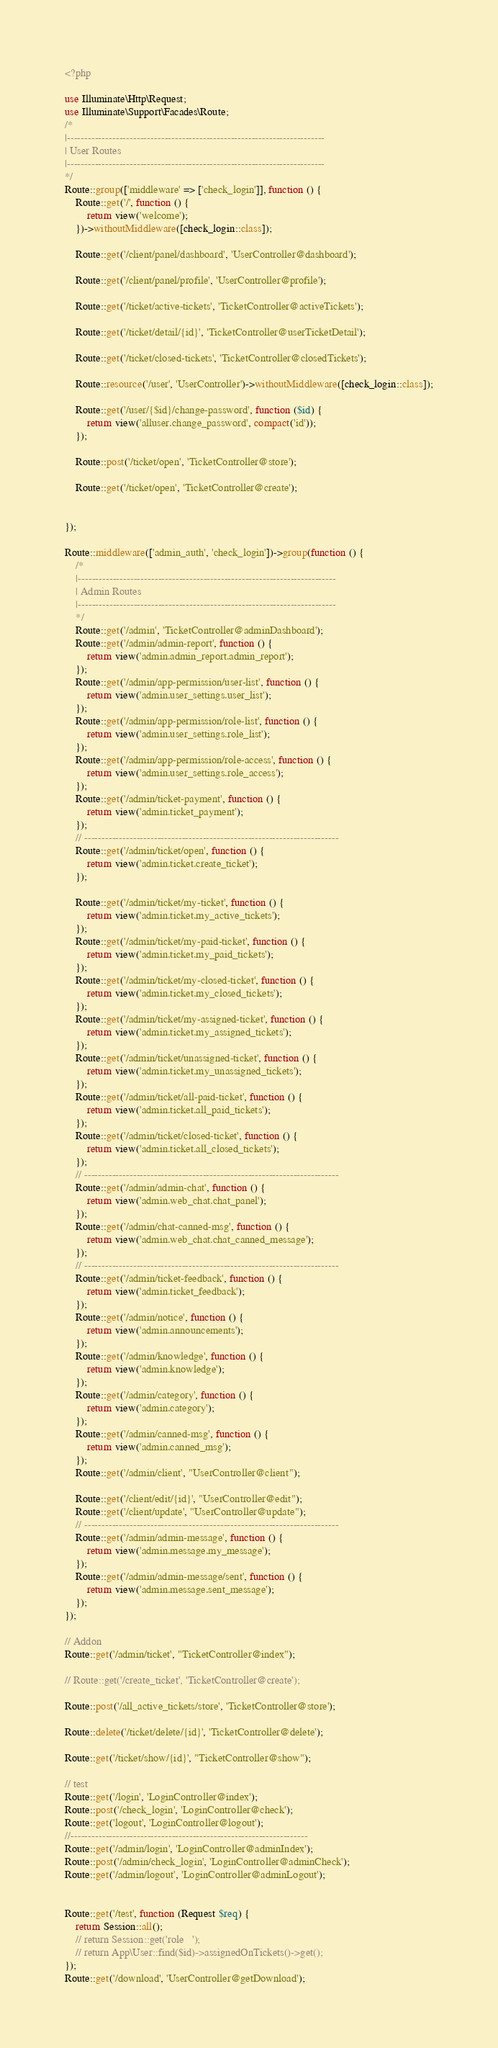Convert code to text. <code><loc_0><loc_0><loc_500><loc_500><_PHP_><?php

use Illuminate\Http\Request;
use Illuminate\Support\Facades\Route;
/*
|--------------------------------------------------------------------------
| User Routes
|--------------------------------------------------------------------------
*/
Route::group(['middleware' => ['check_login']], function () {
    Route::get('/', function () {
        return view('welcome'); 
    })->withoutMiddleware([check_login::class]);

    Route::get('/client/panel/dashboard', 'UserController@dashboard');
    
    Route::get('/client/panel/profile', 'UserController@profile');

    Route::get('/ticket/active-tickets', 'TicketController@activeTickets');

    Route::get('/ticket/detail/{id}', 'TicketController@userTicketDetail');

    Route::get('/ticket/closed-tickets', 'TicketController@closedTickets');

    Route::resource('/user', 'UserController')->withoutMiddleware([check_login::class]);
      
    Route::get('/user/{$id}/change-password', function ($id) {
        return view('alluser.change_password', compact('id'));
    });
    
    Route::post('/ticket/open', 'TicketController@store');

    Route::get('/ticket/open', 'TicketController@create');

    
});

Route::middleware(['admin_auth', 'check_login'])->group(function () {
    /*
    |--------------------------------------------------------------------------
    | Admin Routes
    |--------------------------------------------------------------------------
    */
    Route::get('/admin', 'TicketController@adminDashboard');
    Route::get('/admin/admin-report', function () {
        return view('admin.admin_report.admin_report');
    });
    Route::get('/admin/app-permission/user-list', function () {
        return view('admin.user_settings.user_list');
    });
    Route::get('/admin/app-permission/role-list', function () {
        return view('admin.user_settings.role_list');
    });
    Route::get('/admin/app-permission/role-access', function () {
        return view('admin.user_settings.role_access');
    });
    Route::get('/admin/ticket-payment', function () {
        return view('admin.ticket_payment');
    });
    // -------------------------------------------------------------------------
    Route::get('/admin/ticket/open', function () {
        return view('admin.ticket.create_ticket');
    });

    Route::get('/admin/ticket/my-ticket', function () {
        return view('admin.ticket.my_active_tickets');
    });
    Route::get('/admin/ticket/my-paid-ticket', function () {
        return view('admin.ticket.my_paid_tickets');
    });
    Route::get('/admin/ticket/my-closed-ticket', function () {
        return view('admin.ticket.my_closed_tickets');
    });
    Route::get('/admin/ticket/my-assigned-ticket', function () {
        return view('admin.ticket.my_assigned_tickets');
    });
    Route::get('/admin/ticket/unassigned-ticket', function () {
        return view('admin.ticket.my_unassigned_tickets');
    });
    Route::get('/admin/ticket/all-paid-ticket', function () {
        return view('admin.ticket.all_paid_tickets');
    });
    Route::get('/admin/ticket/closed-ticket', function () {
        return view('admin.ticket.all_closed_tickets');
    });
    // -------------------------------------------------------------------------
    Route::get('/admin/admin-chat', function () {
        return view('admin.web_chat.chat_panel');
    });
    Route::get('/admin/chat-canned-msg', function () {
        return view('admin.web_chat.chat_canned_message');
    });
    // -------------------------------------------------------------------------
    Route::get('/admin/ticket-feedback', function () {
        return view('admin.ticket_feedback');
    });
    Route::get('/admin/notice', function () {
        return view('admin.announcements');
    });
    Route::get('/admin/knowledge', function () {
        return view('admin.knowledge');
    });
    Route::get('/admin/category', function () {
        return view('admin.category');
    });
    Route::get('/admin/canned-msg', function () {
        return view('admin.canned_msg');
    });
    Route::get('/admin/client', "UserController@client");

    Route::get('/client/edit/{id}', "UserController@edit");
    Route::get('/client/update', "UserController@update");
    // -------------------------------------------------------------------------
    Route::get('/admin/admin-message', function () {
        return view('admin.message.my_message');
    });
    Route::get('/admin/admin-message/sent', function () {
        return view('admin.message.sent_message');
    });
});

// Addon
Route::get('/admin/ticket', "TicketController@index");

// Route::get('/create_ticket', 'TicketController@create'); 

Route::post('/all_active_tickets/store', 'TicketController@store');

Route::delete('/ticket/delete/{id}', 'TicketController@delete');

Route::get('/ticket/show/{id}', "TicketController@show");

// test
Route::get('/login', 'LoginController@index');
Route::post('/check_login', 'LoginController@check');
Route::get('logout', 'LoginController@logout');
//--------------------------------------------------------------------
Route::get('/admin/login', 'LoginController@adminIndex');
Route::post('/admin/check_login', 'LoginController@adminCheck');
Route::get('/admin/logout', 'LoginController@adminLogout');


Route::get('/test', function (Request $req) {
    return Session::all();
    // return Session::get('role   ');
    // return App\User::find($id)->assignedOnTickets()->get();
});
Route::get('/download', 'UserController@getDownload');</code> 